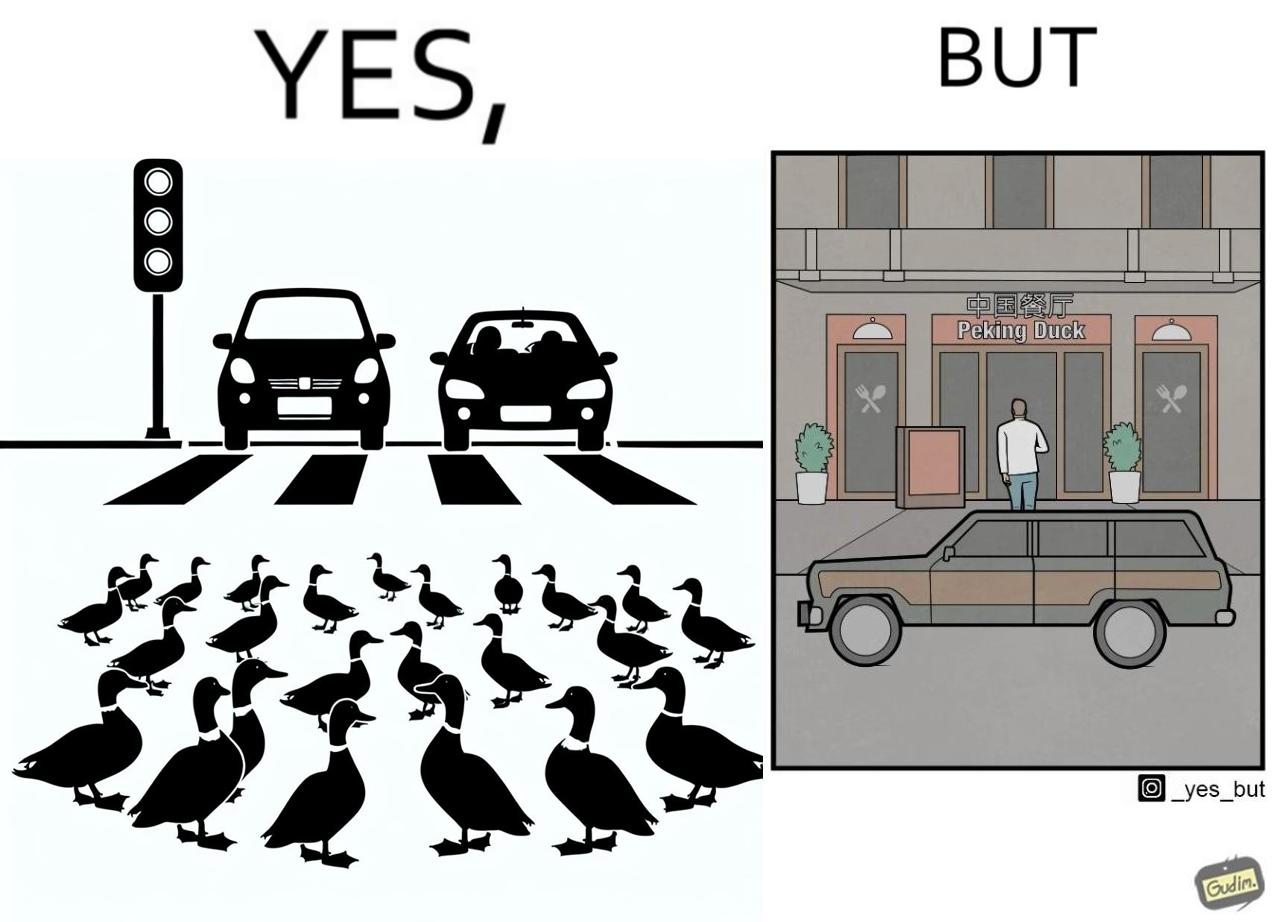Is this image satirical or non-satirical? Yes, this image is satirical. 